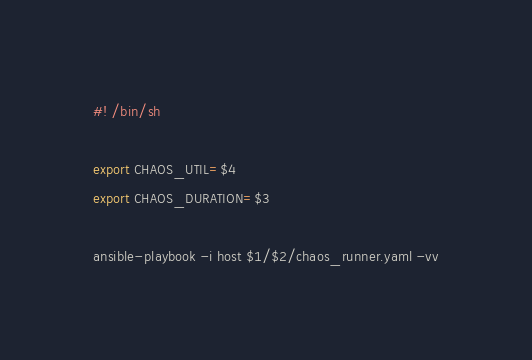Convert code to text. <code><loc_0><loc_0><loc_500><loc_500><_Bash_>#! /bin/sh

export CHAOS_UTIL=$4
export CHAOS_DURATION=$3

ansible-playbook -i host $1/$2/chaos_runner.yaml -vv</code> 